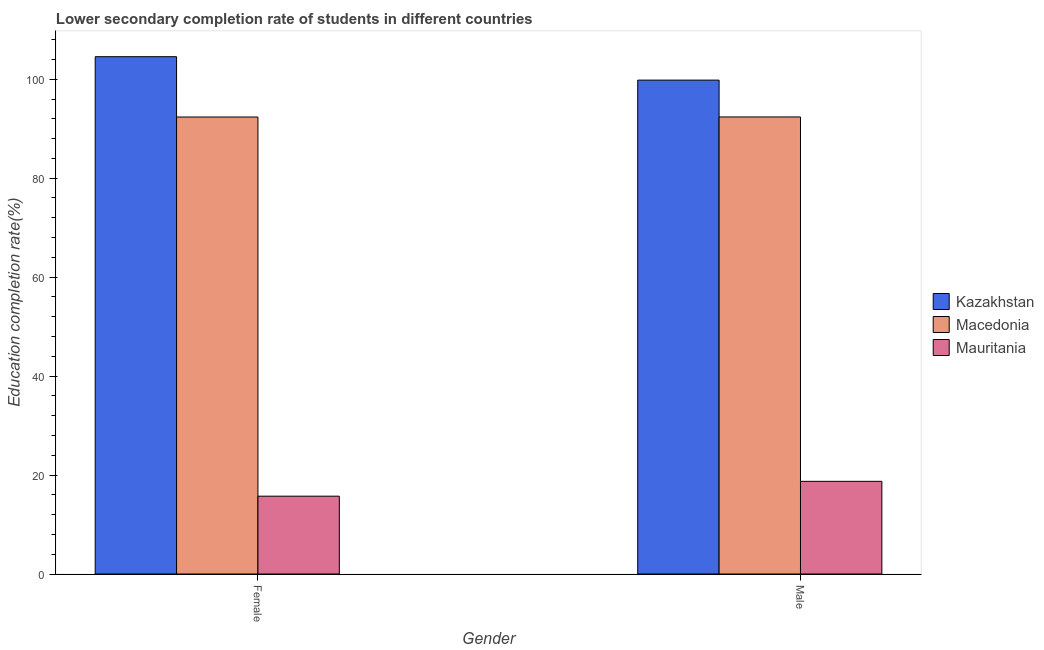How many groups of bars are there?
Make the answer very short. 2. Are the number of bars per tick equal to the number of legend labels?
Make the answer very short. Yes. How many bars are there on the 2nd tick from the left?
Keep it short and to the point. 3. How many bars are there on the 2nd tick from the right?
Your answer should be very brief. 3. What is the education completion rate of male students in Kazakhstan?
Ensure brevity in your answer.  99.82. Across all countries, what is the maximum education completion rate of male students?
Your answer should be very brief. 99.82. Across all countries, what is the minimum education completion rate of male students?
Ensure brevity in your answer.  18.73. In which country was the education completion rate of female students maximum?
Provide a succinct answer. Kazakhstan. In which country was the education completion rate of female students minimum?
Provide a succinct answer. Mauritania. What is the total education completion rate of male students in the graph?
Provide a succinct answer. 210.93. What is the difference between the education completion rate of male students in Macedonia and that in Mauritania?
Offer a very short reply. 73.65. What is the difference between the education completion rate of female students in Macedonia and the education completion rate of male students in Mauritania?
Offer a terse response. 73.64. What is the average education completion rate of female students per country?
Keep it short and to the point. 70.88. What is the difference between the education completion rate of male students and education completion rate of female students in Kazakhstan?
Your answer should be very brief. -4.74. What is the ratio of the education completion rate of female students in Macedonia to that in Kazakhstan?
Keep it short and to the point. 0.88. What does the 3rd bar from the left in Male represents?
Give a very brief answer. Mauritania. What does the 3rd bar from the right in Female represents?
Make the answer very short. Kazakhstan. How many bars are there?
Provide a short and direct response. 6. Does the graph contain grids?
Your response must be concise. No. What is the title of the graph?
Keep it short and to the point. Lower secondary completion rate of students in different countries. What is the label or title of the X-axis?
Your answer should be very brief. Gender. What is the label or title of the Y-axis?
Make the answer very short. Education completion rate(%). What is the Education completion rate(%) of Kazakhstan in Female?
Your response must be concise. 104.56. What is the Education completion rate(%) in Macedonia in Female?
Offer a very short reply. 92.37. What is the Education completion rate(%) of Mauritania in Female?
Your answer should be very brief. 15.73. What is the Education completion rate(%) of Kazakhstan in Male?
Provide a short and direct response. 99.82. What is the Education completion rate(%) of Macedonia in Male?
Give a very brief answer. 92.38. What is the Education completion rate(%) of Mauritania in Male?
Ensure brevity in your answer.  18.73. Across all Gender, what is the maximum Education completion rate(%) of Kazakhstan?
Offer a terse response. 104.56. Across all Gender, what is the maximum Education completion rate(%) of Macedonia?
Provide a succinct answer. 92.38. Across all Gender, what is the maximum Education completion rate(%) of Mauritania?
Your answer should be very brief. 18.73. Across all Gender, what is the minimum Education completion rate(%) of Kazakhstan?
Offer a very short reply. 99.82. Across all Gender, what is the minimum Education completion rate(%) in Macedonia?
Offer a terse response. 92.37. Across all Gender, what is the minimum Education completion rate(%) in Mauritania?
Your response must be concise. 15.73. What is the total Education completion rate(%) of Kazakhstan in the graph?
Offer a very short reply. 204.38. What is the total Education completion rate(%) in Macedonia in the graph?
Your answer should be compact. 184.75. What is the total Education completion rate(%) of Mauritania in the graph?
Your answer should be very brief. 34.46. What is the difference between the Education completion rate(%) of Kazakhstan in Female and that in Male?
Your answer should be very brief. 4.74. What is the difference between the Education completion rate(%) in Macedonia in Female and that in Male?
Ensure brevity in your answer.  -0.01. What is the difference between the Education completion rate(%) in Mauritania in Female and that in Male?
Ensure brevity in your answer.  -3. What is the difference between the Education completion rate(%) in Kazakhstan in Female and the Education completion rate(%) in Macedonia in Male?
Ensure brevity in your answer.  12.18. What is the difference between the Education completion rate(%) in Kazakhstan in Female and the Education completion rate(%) in Mauritania in Male?
Your answer should be compact. 85.83. What is the difference between the Education completion rate(%) in Macedonia in Female and the Education completion rate(%) in Mauritania in Male?
Make the answer very short. 73.64. What is the average Education completion rate(%) of Kazakhstan per Gender?
Offer a very short reply. 102.19. What is the average Education completion rate(%) of Macedonia per Gender?
Offer a very short reply. 92.37. What is the average Education completion rate(%) in Mauritania per Gender?
Provide a short and direct response. 17.23. What is the difference between the Education completion rate(%) in Kazakhstan and Education completion rate(%) in Macedonia in Female?
Your response must be concise. 12.19. What is the difference between the Education completion rate(%) in Kazakhstan and Education completion rate(%) in Mauritania in Female?
Ensure brevity in your answer.  88.83. What is the difference between the Education completion rate(%) of Macedonia and Education completion rate(%) of Mauritania in Female?
Your response must be concise. 76.64. What is the difference between the Education completion rate(%) of Kazakhstan and Education completion rate(%) of Macedonia in Male?
Give a very brief answer. 7.44. What is the difference between the Education completion rate(%) in Kazakhstan and Education completion rate(%) in Mauritania in Male?
Your answer should be very brief. 81.09. What is the difference between the Education completion rate(%) in Macedonia and Education completion rate(%) in Mauritania in Male?
Keep it short and to the point. 73.65. What is the ratio of the Education completion rate(%) in Kazakhstan in Female to that in Male?
Offer a terse response. 1.05. What is the ratio of the Education completion rate(%) in Mauritania in Female to that in Male?
Provide a short and direct response. 0.84. What is the difference between the highest and the second highest Education completion rate(%) of Kazakhstan?
Offer a very short reply. 4.74. What is the difference between the highest and the second highest Education completion rate(%) of Macedonia?
Your response must be concise. 0.01. What is the difference between the highest and the second highest Education completion rate(%) in Mauritania?
Your answer should be compact. 3. What is the difference between the highest and the lowest Education completion rate(%) in Kazakhstan?
Your response must be concise. 4.74. What is the difference between the highest and the lowest Education completion rate(%) in Macedonia?
Your answer should be very brief. 0.01. What is the difference between the highest and the lowest Education completion rate(%) in Mauritania?
Offer a very short reply. 3. 